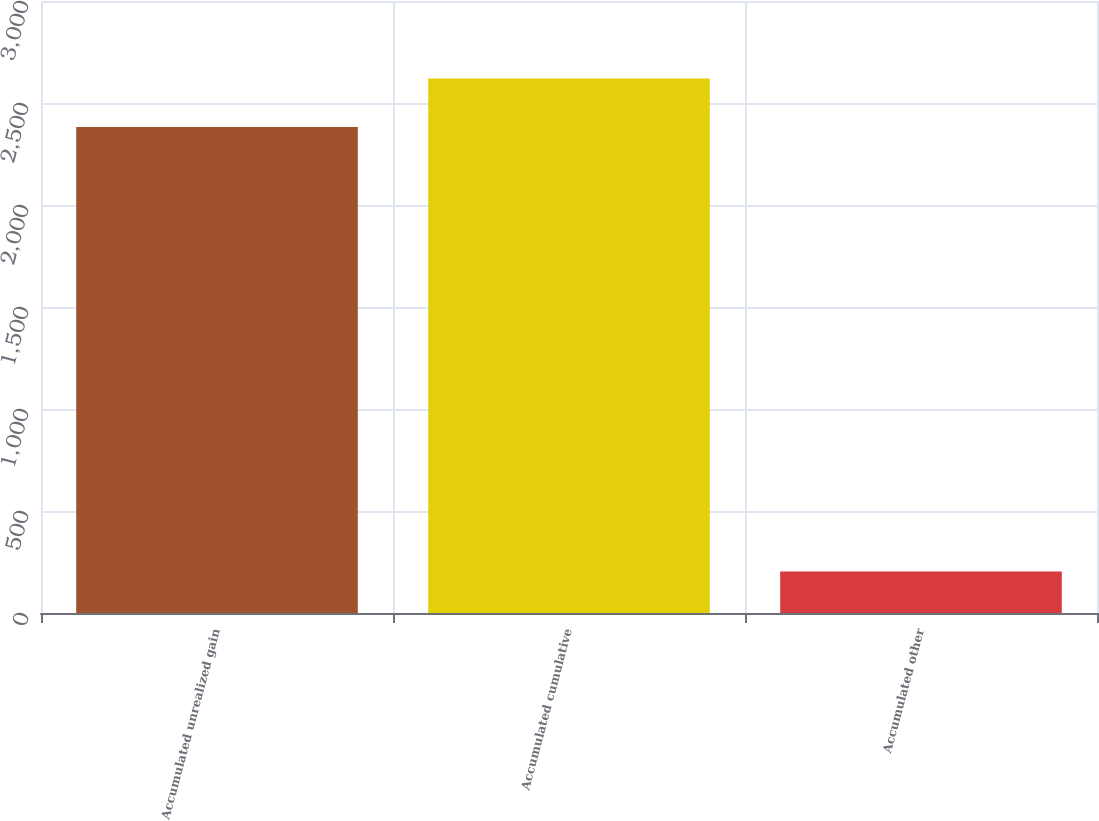Convert chart to OTSL. <chart><loc_0><loc_0><loc_500><loc_500><bar_chart><fcel>Accumulated unrealized gain<fcel>Accumulated cumulative<fcel>Accumulated other<nl><fcel>2382<fcel>2620.2<fcel>204<nl></chart> 